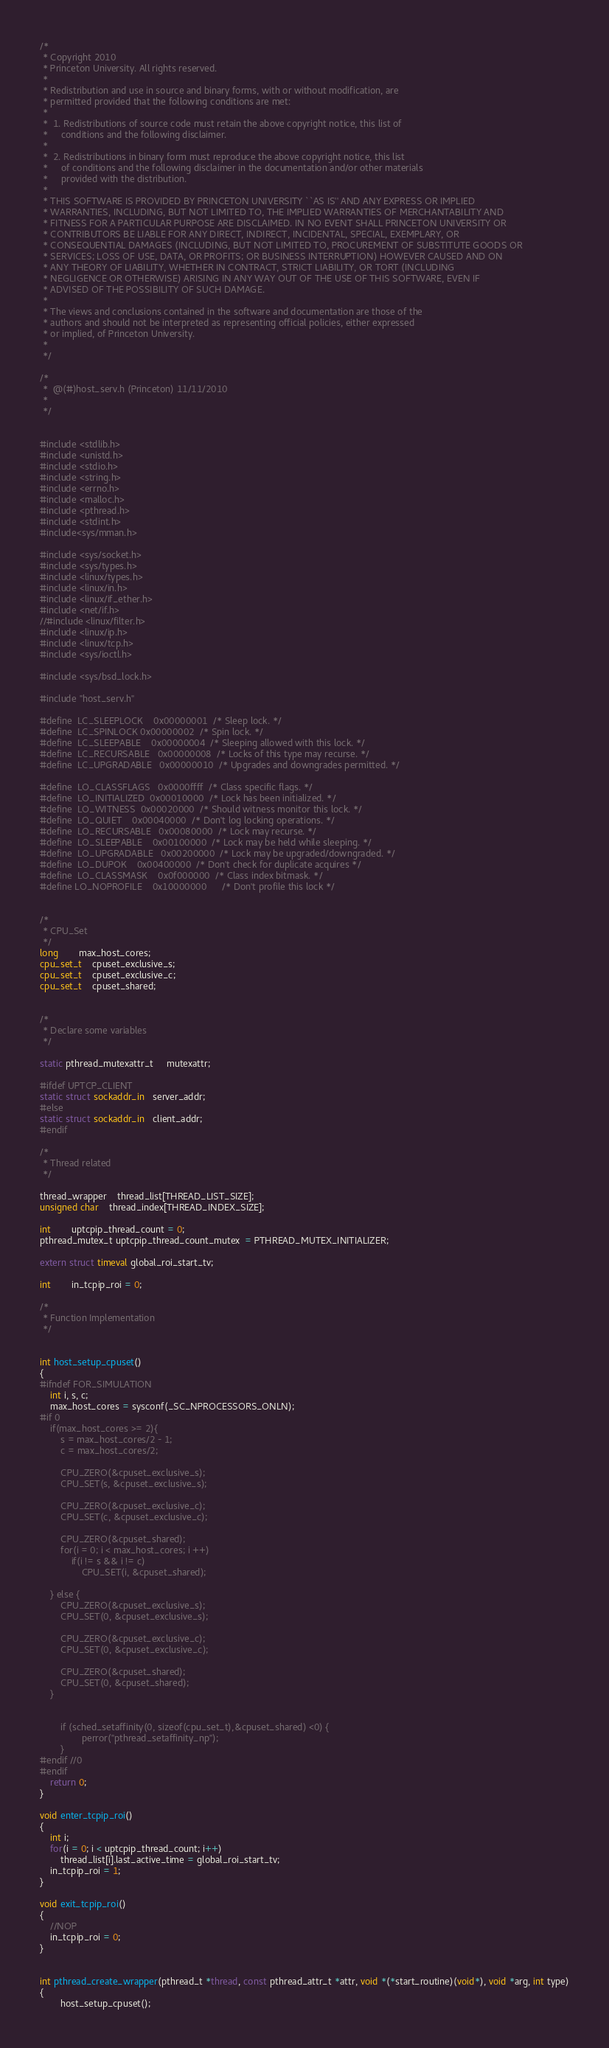<code> <loc_0><loc_0><loc_500><loc_500><_C_>/*
 * Copyright 2010
 * Princeton University. All rights reserved.
 *
 * Redistribution and use in source and binary forms, with or without modification, are
 * permitted provided that the following conditions are met:
 *
 *  1. Redistributions of source code must retain the above copyright notice, this list of
 *     conditions and the following disclaimer.
 *
 *  2. Redistributions in binary form must reproduce the above copyright notice, this list
 *     of conditions and the following disclaimer in the documentation and/or other materials
 *     provided with the distribution.
 *
 * THIS SOFTWARE IS PROVIDED BY PRINCETON UNIVERSITY ``AS IS'' AND ANY EXPRESS OR IMPLIED
 * WARRANTIES, INCLUDING, BUT NOT LIMITED TO, THE IMPLIED WARRANTIES OF MERCHANTABILITY AND
 * FITNESS FOR A PARTICULAR PURPOSE ARE DISCLAIMED. IN NO EVENT SHALL PRINCETON UNIVERSITY OR
 * CONTRIBUTORS BE LIABLE FOR ANY DIRECT, INDIRECT, INCIDENTAL, SPECIAL, EXEMPLARY, OR
 * CONSEQUENTIAL DAMAGES (INCLUDING, BUT NOT LIMITED TO, PROCUREMENT OF SUBSTITUTE GOODS OR
 * SERVICES; LOSS OF USE, DATA, OR PROFITS; OR BUSINESS INTERRUPTION) HOWEVER CAUSED AND ON
 * ANY THEORY OF LIABILITY, WHETHER IN CONTRACT, STRICT LIABILITY, OR TORT (INCLUDING
 * NEGLIGENCE OR OTHERWISE) ARISING IN ANY WAY OUT OF THE USE OF THIS SOFTWARE, EVEN IF
 * ADVISED OF THE POSSIBILITY OF SUCH DAMAGE.
 *
 * The views and conclusions contained in the software and documentation are those of the
 * authors and should not be interpreted as representing official policies, either expressed
 * or implied, of Princeton University.
 *
 */

/* 
 *	@(#)host_serv.h	(Princeton) 11/11/2010
 *  
 */


#include <stdlib.h>
#include <unistd.h>
#include <stdio.h>
#include <string.h>
#include <errno.h>
#include <malloc.h>
#include <pthread.h>
#include <stdint.h>
#include<sys/mman.h>

#include <sys/socket.h>
#include <sys/types.h>
#include <linux/types.h>
#include <linux/in.h>
#include <linux/if_ether.h>
#include <net/if.h>
//#include <linux/filter.h>
#include <linux/ip.h>
#include <linux/tcp.h>
#include <sys/ioctl.h>

#include <sys/bsd_lock.h>

#include "host_serv.h"

#define	LC_SLEEPLOCK	0x00000001	/* Sleep lock. */
#define	LC_SPINLOCK	0x00000002	/* Spin lock. */
#define	LC_SLEEPABLE	0x00000004	/* Sleeping allowed with this lock. */
#define	LC_RECURSABLE	0x00000008	/* Locks of this type may recurse. */
#define	LC_UPGRADABLE	0x00000010	/* Upgrades and downgrades permitted. */

#define	LO_CLASSFLAGS	0x0000ffff	/* Class specific flags. */
#define	LO_INITIALIZED	0x00010000	/* Lock has been initialized. */
#define	LO_WITNESS	0x00020000	/* Should witness monitor this lock. */
#define	LO_QUIET	0x00040000	/* Don't log locking operations. */
#define	LO_RECURSABLE	0x00080000	/* Lock may recurse. */
#define	LO_SLEEPABLE	0x00100000	/* Lock may be held while sleeping. */
#define	LO_UPGRADABLE	0x00200000	/* Lock may be upgraded/downgraded. */
#define	LO_DUPOK	0x00400000	/* Don't check for duplicate acquires */
#define	LO_CLASSMASK	0x0f000000	/* Class index bitmask. */
#define LO_NOPROFILE    0x10000000      /* Don't profile this lock */


/*
 * CPU_Set
 */
long		max_host_cores;
cpu_set_t 	cpuset_exclusive_s;
cpu_set_t 	cpuset_exclusive_c;
cpu_set_t	cpuset_shared;


/*
 * Declare some variables
 */

static pthread_mutexattr_t	 mutexattr;

#ifdef UPTCP_CLIENT
static struct sockaddr_in   server_addr;
#else
static struct sockaddr_in   client_addr;
#endif

/*
 * Thread related
 */ 

thread_wrapper	thread_list[THREAD_LIST_SIZE];
unsigned char	thread_index[THREAD_INDEX_SIZE]; 

int		uptcpip_thread_count = 0;
pthread_mutex_t uptcpip_thread_count_mutex  = PTHREAD_MUTEX_INITIALIZER;

extern struct timeval global_roi_start_tv;

int		in_tcpip_roi = 0;

/*
 * Function Implementation
 */ 


int host_setup_cpuset()
{
#ifndef FOR_SIMULATION
	int i, s, c;
	max_host_cores = sysconf(_SC_NPROCESSORS_ONLN);
#if 0
	if(max_host_cores >= 2){
		s = max_host_cores/2 - 1;
		c = max_host_cores/2;

		CPU_ZERO(&cpuset_exclusive_s);
		CPU_SET(s, &cpuset_exclusive_s);

		CPU_ZERO(&cpuset_exclusive_c);
		CPU_SET(c, &cpuset_exclusive_c);

		CPU_ZERO(&cpuset_shared);
		for(i = 0; i < max_host_cores; i ++)
			if(i != s && i != c)
				CPU_SET(i, &cpuset_shared);

	} else {
		CPU_ZERO(&cpuset_exclusive_s);
		CPU_SET(0, &cpuset_exclusive_s);

		CPU_ZERO(&cpuset_exclusive_c);
		CPU_SET(0, &cpuset_exclusive_c);

		CPU_ZERO(&cpuset_shared);
		CPU_SET(0, &cpuset_shared);
	}
	

        if (sched_setaffinity(0, sizeof(cpu_set_t),&cpuset_shared) <0) {
                perror("pthread_setaffinity_np");
        }
#endif //0
#endif
	return 0;
}

void enter_tcpip_roi()
{
	int i;
	for(i = 0; i < uptcpip_thread_count; i++)
		thread_list[i].last_active_time = global_roi_start_tv;
	in_tcpip_roi = 1;
}

void exit_tcpip_roi()
{
	//NOP
	in_tcpip_roi = 0;
}


int pthread_create_wrapper(pthread_t *thread, const pthread_attr_t *attr, void *(*start_routine)(void*), void *arg, int type)
{
        host_setup_cpuset();</code> 